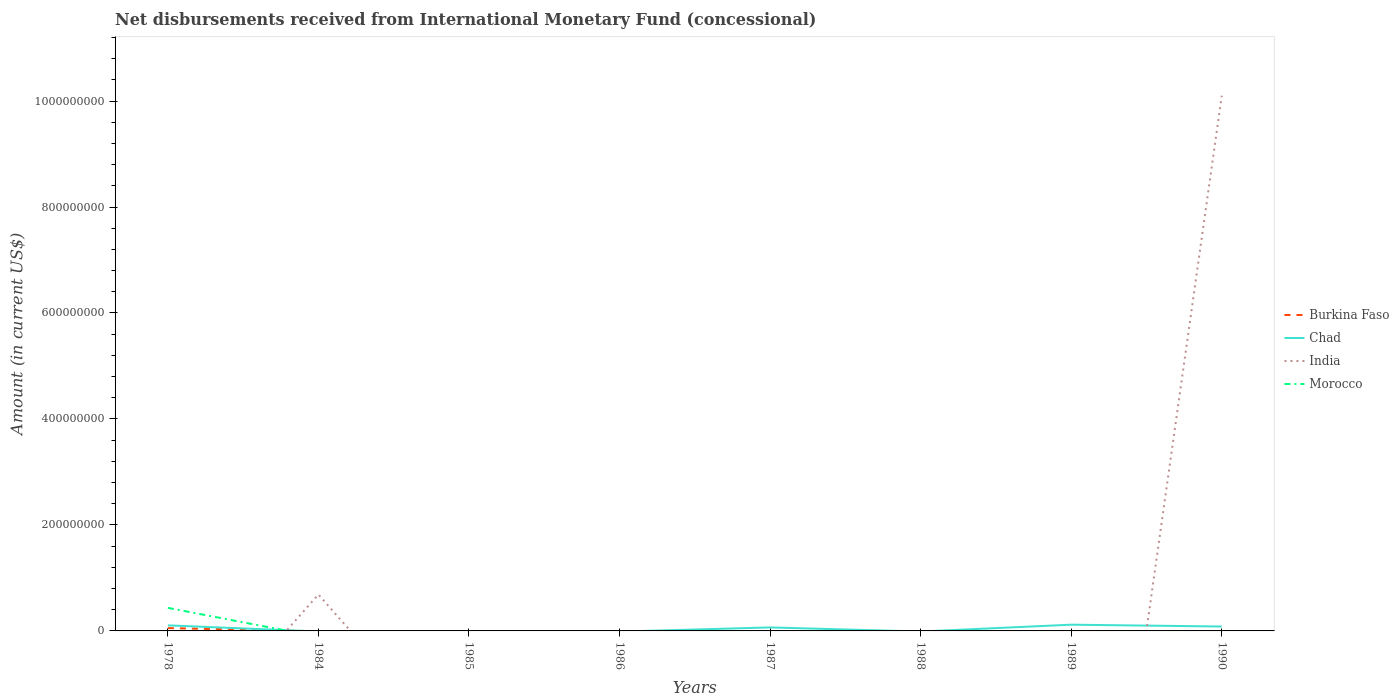How many different coloured lines are there?
Keep it short and to the point. 4. What is the total amount of disbursements received from International Monetary Fund in Chad in the graph?
Keep it short and to the point. 3.47e+06. What is the difference between the highest and the second highest amount of disbursements received from International Monetary Fund in Morocco?
Make the answer very short. 4.35e+07. How many lines are there?
Provide a short and direct response. 4. Are the values on the major ticks of Y-axis written in scientific E-notation?
Your answer should be compact. No. Where does the legend appear in the graph?
Keep it short and to the point. Center right. How are the legend labels stacked?
Ensure brevity in your answer.  Vertical. What is the title of the graph?
Provide a short and direct response. Net disbursements received from International Monetary Fund (concessional). What is the label or title of the Y-axis?
Offer a very short reply. Amount (in current US$). What is the Amount (in current US$) of Burkina Faso in 1978?
Provide a succinct answer. 5.34e+06. What is the Amount (in current US$) of Chad in 1978?
Ensure brevity in your answer.  1.05e+07. What is the Amount (in current US$) in Morocco in 1978?
Provide a short and direct response. 4.35e+07. What is the Amount (in current US$) in Chad in 1984?
Offer a terse response. 0. What is the Amount (in current US$) in India in 1984?
Provide a short and direct response. 6.87e+07. What is the Amount (in current US$) in Morocco in 1984?
Provide a short and direct response. 0. What is the Amount (in current US$) in Burkina Faso in 1985?
Provide a short and direct response. 0. What is the Amount (in current US$) of Burkina Faso in 1986?
Make the answer very short. 0. What is the Amount (in current US$) in Morocco in 1986?
Provide a short and direct response. 0. What is the Amount (in current US$) of Chad in 1987?
Offer a very short reply. 6.60e+06. What is the Amount (in current US$) of Morocco in 1987?
Keep it short and to the point. 0. What is the Amount (in current US$) in Burkina Faso in 1989?
Your answer should be very brief. 0. What is the Amount (in current US$) in Chad in 1989?
Your answer should be very brief. 1.18e+07. What is the Amount (in current US$) in India in 1989?
Offer a very short reply. 0. What is the Amount (in current US$) in Burkina Faso in 1990?
Your answer should be very brief. 0. What is the Amount (in current US$) in Chad in 1990?
Offer a very short reply. 8.31e+06. What is the Amount (in current US$) of India in 1990?
Your answer should be very brief. 1.01e+09. What is the Amount (in current US$) in Morocco in 1990?
Offer a terse response. 0. Across all years, what is the maximum Amount (in current US$) of Burkina Faso?
Provide a short and direct response. 5.34e+06. Across all years, what is the maximum Amount (in current US$) in Chad?
Offer a very short reply. 1.18e+07. Across all years, what is the maximum Amount (in current US$) in India?
Provide a succinct answer. 1.01e+09. Across all years, what is the maximum Amount (in current US$) in Morocco?
Make the answer very short. 4.35e+07. Across all years, what is the minimum Amount (in current US$) of Burkina Faso?
Make the answer very short. 0. Across all years, what is the minimum Amount (in current US$) in Chad?
Offer a very short reply. 0. Across all years, what is the minimum Amount (in current US$) of Morocco?
Your answer should be very brief. 0. What is the total Amount (in current US$) of Burkina Faso in the graph?
Give a very brief answer. 5.34e+06. What is the total Amount (in current US$) of Chad in the graph?
Your response must be concise. 3.72e+07. What is the total Amount (in current US$) of India in the graph?
Your response must be concise. 1.08e+09. What is the total Amount (in current US$) in Morocco in the graph?
Offer a terse response. 4.35e+07. What is the difference between the Amount (in current US$) of Chad in 1978 and that in 1987?
Provide a short and direct response. 3.90e+06. What is the difference between the Amount (in current US$) of Chad in 1978 and that in 1989?
Make the answer very short. -1.27e+06. What is the difference between the Amount (in current US$) in Chad in 1978 and that in 1990?
Offer a terse response. 2.20e+06. What is the difference between the Amount (in current US$) of India in 1984 and that in 1990?
Keep it short and to the point. -9.41e+08. What is the difference between the Amount (in current US$) in Chad in 1987 and that in 1989?
Make the answer very short. -5.17e+06. What is the difference between the Amount (in current US$) of Chad in 1987 and that in 1990?
Keep it short and to the point. -1.70e+06. What is the difference between the Amount (in current US$) of Chad in 1989 and that in 1990?
Provide a succinct answer. 3.47e+06. What is the difference between the Amount (in current US$) of Burkina Faso in 1978 and the Amount (in current US$) of India in 1984?
Ensure brevity in your answer.  -6.34e+07. What is the difference between the Amount (in current US$) in Chad in 1978 and the Amount (in current US$) in India in 1984?
Offer a very short reply. -5.82e+07. What is the difference between the Amount (in current US$) in Burkina Faso in 1978 and the Amount (in current US$) in Chad in 1987?
Your answer should be compact. -1.26e+06. What is the difference between the Amount (in current US$) in Burkina Faso in 1978 and the Amount (in current US$) in Chad in 1989?
Make the answer very short. -6.44e+06. What is the difference between the Amount (in current US$) of Burkina Faso in 1978 and the Amount (in current US$) of Chad in 1990?
Provide a short and direct response. -2.97e+06. What is the difference between the Amount (in current US$) in Burkina Faso in 1978 and the Amount (in current US$) in India in 1990?
Your answer should be compact. -1.00e+09. What is the difference between the Amount (in current US$) in Chad in 1978 and the Amount (in current US$) in India in 1990?
Your response must be concise. -1.00e+09. What is the difference between the Amount (in current US$) in Chad in 1987 and the Amount (in current US$) in India in 1990?
Provide a succinct answer. -1.00e+09. What is the difference between the Amount (in current US$) in Chad in 1989 and the Amount (in current US$) in India in 1990?
Your response must be concise. -9.98e+08. What is the average Amount (in current US$) of Burkina Faso per year?
Give a very brief answer. 6.67e+05. What is the average Amount (in current US$) in Chad per year?
Your answer should be very brief. 4.65e+06. What is the average Amount (in current US$) of India per year?
Your answer should be compact. 1.35e+08. What is the average Amount (in current US$) of Morocco per year?
Your response must be concise. 5.44e+06. In the year 1978, what is the difference between the Amount (in current US$) in Burkina Faso and Amount (in current US$) in Chad?
Provide a short and direct response. -5.17e+06. In the year 1978, what is the difference between the Amount (in current US$) in Burkina Faso and Amount (in current US$) in Morocco?
Give a very brief answer. -3.82e+07. In the year 1978, what is the difference between the Amount (in current US$) in Chad and Amount (in current US$) in Morocco?
Ensure brevity in your answer.  -3.30e+07. In the year 1990, what is the difference between the Amount (in current US$) of Chad and Amount (in current US$) of India?
Keep it short and to the point. -1.00e+09. What is the ratio of the Amount (in current US$) in Chad in 1978 to that in 1987?
Give a very brief answer. 1.59. What is the ratio of the Amount (in current US$) in Chad in 1978 to that in 1989?
Provide a short and direct response. 0.89. What is the ratio of the Amount (in current US$) of Chad in 1978 to that in 1990?
Your response must be concise. 1.26. What is the ratio of the Amount (in current US$) in India in 1984 to that in 1990?
Provide a succinct answer. 0.07. What is the ratio of the Amount (in current US$) of Chad in 1987 to that in 1989?
Make the answer very short. 0.56. What is the ratio of the Amount (in current US$) of Chad in 1987 to that in 1990?
Your answer should be compact. 0.79. What is the ratio of the Amount (in current US$) in Chad in 1989 to that in 1990?
Keep it short and to the point. 1.42. What is the difference between the highest and the second highest Amount (in current US$) of Chad?
Offer a very short reply. 1.27e+06. What is the difference between the highest and the lowest Amount (in current US$) of Burkina Faso?
Provide a succinct answer. 5.34e+06. What is the difference between the highest and the lowest Amount (in current US$) in Chad?
Your response must be concise. 1.18e+07. What is the difference between the highest and the lowest Amount (in current US$) of India?
Provide a succinct answer. 1.01e+09. What is the difference between the highest and the lowest Amount (in current US$) in Morocco?
Your answer should be compact. 4.35e+07. 